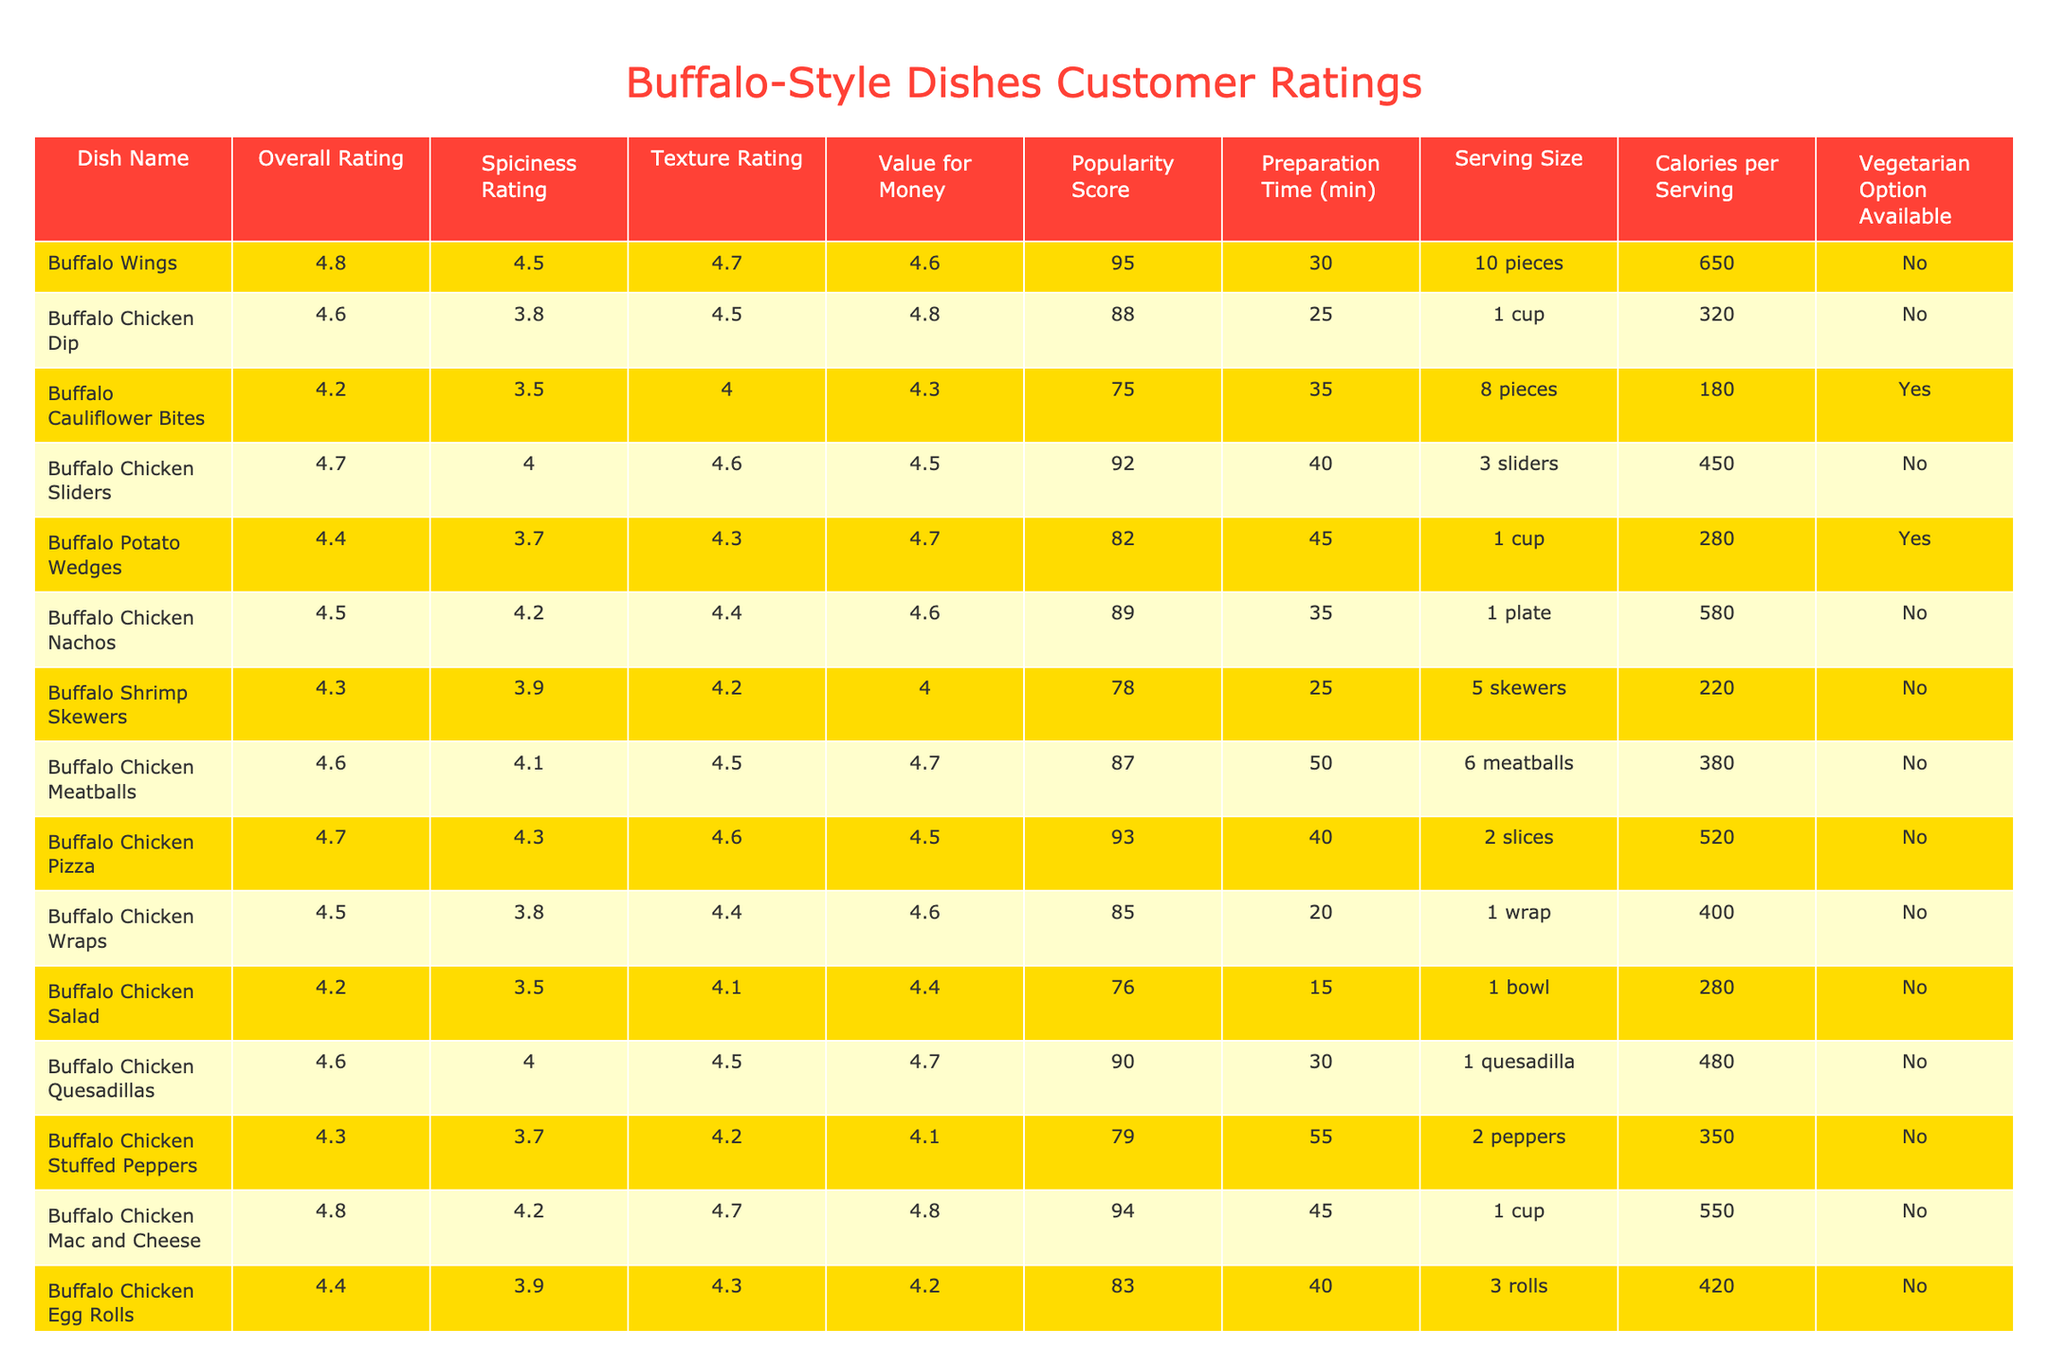What is the overall rating of Buffalo Wings? The overall rating for Buffalo Wings is listed in the table, which shows a value of 4.8.
Answer: 4.8 Which dish has the highest popularity score? The popularity score for each dish is compared, and Buffalo Wings have the highest score at 95.
Answer: 95 Are there any vegetarian options available among the dishes? The table indicates that Buffalo Cauliflower Bites and Buffalo Potato Wedges have a vegetarian option available, thus confirming that there are vegetarian options.
Answer: Yes What is the preparation time for Buffalo Chicken Pizza? The table lists the preparation time for Buffalo Chicken Pizza as 40 minutes.
Answer: 40 minutes How many calories does Buffalo Chicken Dip have per serving? Referring to the table, Buffalo Chicken Dip has 320 calories per serving.
Answer: 320 calories Which dish has the lowest texture rating? Comparing the texture ratings in the table, Buffalo Cauliflower Bites have the lowest texture rating of 4.0.
Answer: 4.0 What is the average spiciness rating of all the dishes? The spiciness ratings are summed up: (4.5 + 3.8 + 3.5 + 4.0 + 3.7 + 4.2 + 3.9 + 4.1 + 4.3 + 3.8 + 4.0 + 3.7 + 4.2) = 51.7. There are 13 dishes, so the average spiciness rating is 51.7 / 13 ≈ 4.0.
Answer: 4.0 Is Buffalo Chicken Salad a vegetarian option? The table indicates that Buffalo Chicken Salad does not have a vegetarian option available, confirming that it is not vegetarian.
Answer: No Which dish has the highest overall rating and how much is it? Buffalo Wings with an overall rating of 4.8 has the highest overall rating based on the table.
Answer: 4.8 What is the difference in calories between Buffalo Chicken Mac and Cheese and Buffalo Chicken Salad? The calories for Buffalo Chicken Mac and Cheese (550) and Buffalo Chicken Salad (280) are taken, and the difference is calculated: 550 - 280 = 270.
Answer: 270 calories How many dishes have an overall rating of 4.5 or higher? Counting the dishes from the table, there are 8 dishes with an overall rating of 4.5 or higher: Buffalo Wings, Buffalo Chicken Dip, Buffalo Chicken Sliders, Buffalo Chicken Nachos, Buffalo Chicken Quesadillas, Buffalo Chicken Mac and Cheese, Buffalo Chicken Pizza, and Buffalo Chicken Wraps.
Answer: 8 dishes 